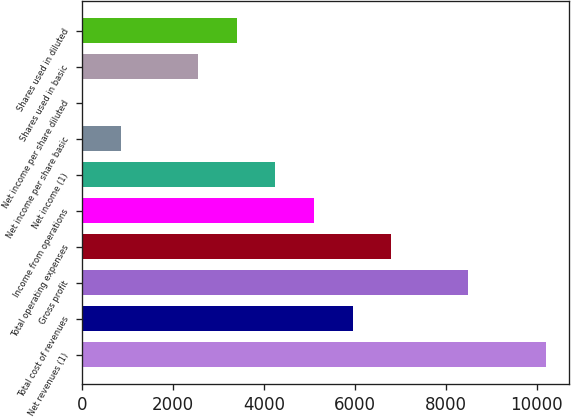Convert chart. <chart><loc_0><loc_0><loc_500><loc_500><bar_chart><fcel>Net revenues (1)<fcel>Total cost of revenues<fcel>Gross profit<fcel>Total operating expenses<fcel>Income from operations<fcel>Net income (1)<fcel>Net income per share basic<fcel>Net income per share diluted<fcel>Shares used in basic<fcel>Shares used in diluted<nl><fcel>10198.2<fcel>5949.68<fcel>8498.81<fcel>6799.39<fcel>5099.97<fcel>4250.26<fcel>851.42<fcel>1.71<fcel>2550.84<fcel>3400.55<nl></chart> 